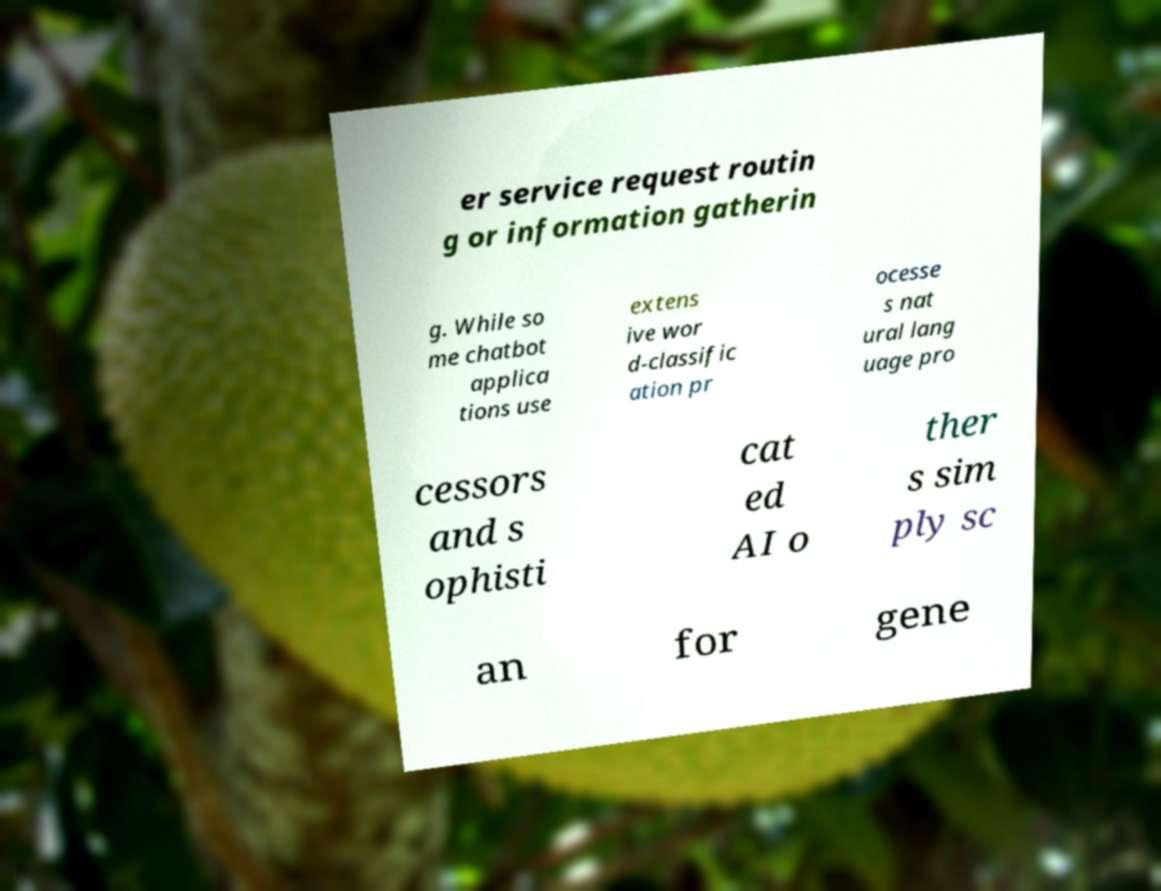Please read and relay the text visible in this image. What does it say? er service request routin g or information gatherin g. While so me chatbot applica tions use extens ive wor d-classific ation pr ocesse s nat ural lang uage pro cessors and s ophisti cat ed AI o ther s sim ply sc an for gene 